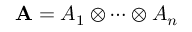<formula> <loc_0><loc_0><loc_500><loc_500>A = A _ { 1 } \otimes \cdots \otimes A _ { n }</formula> 